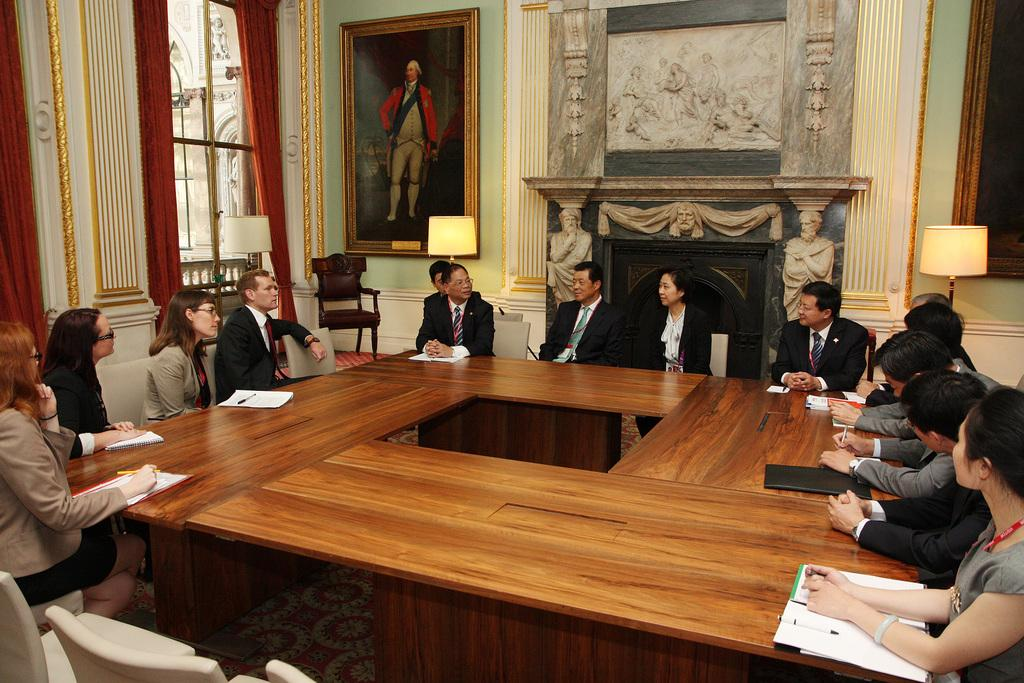What is happening in the image? A meeting is taking place in the image. What are the people in the image doing? People are sitting and discussing. Can you describe any objects in the background of the image? There is a photo frame visible in the background. What is on the left side of the image? There are windows on the left side of the image. What type of curtains are near the windows? Red curtains are present near the windows. What type of leather is used to make the cast visible on the table? There is no cast visible on the table in the image. What type of flag is being waved by the people during the meeting? There is no flag present in the image; it is a meeting where people are sitting and discussing. 